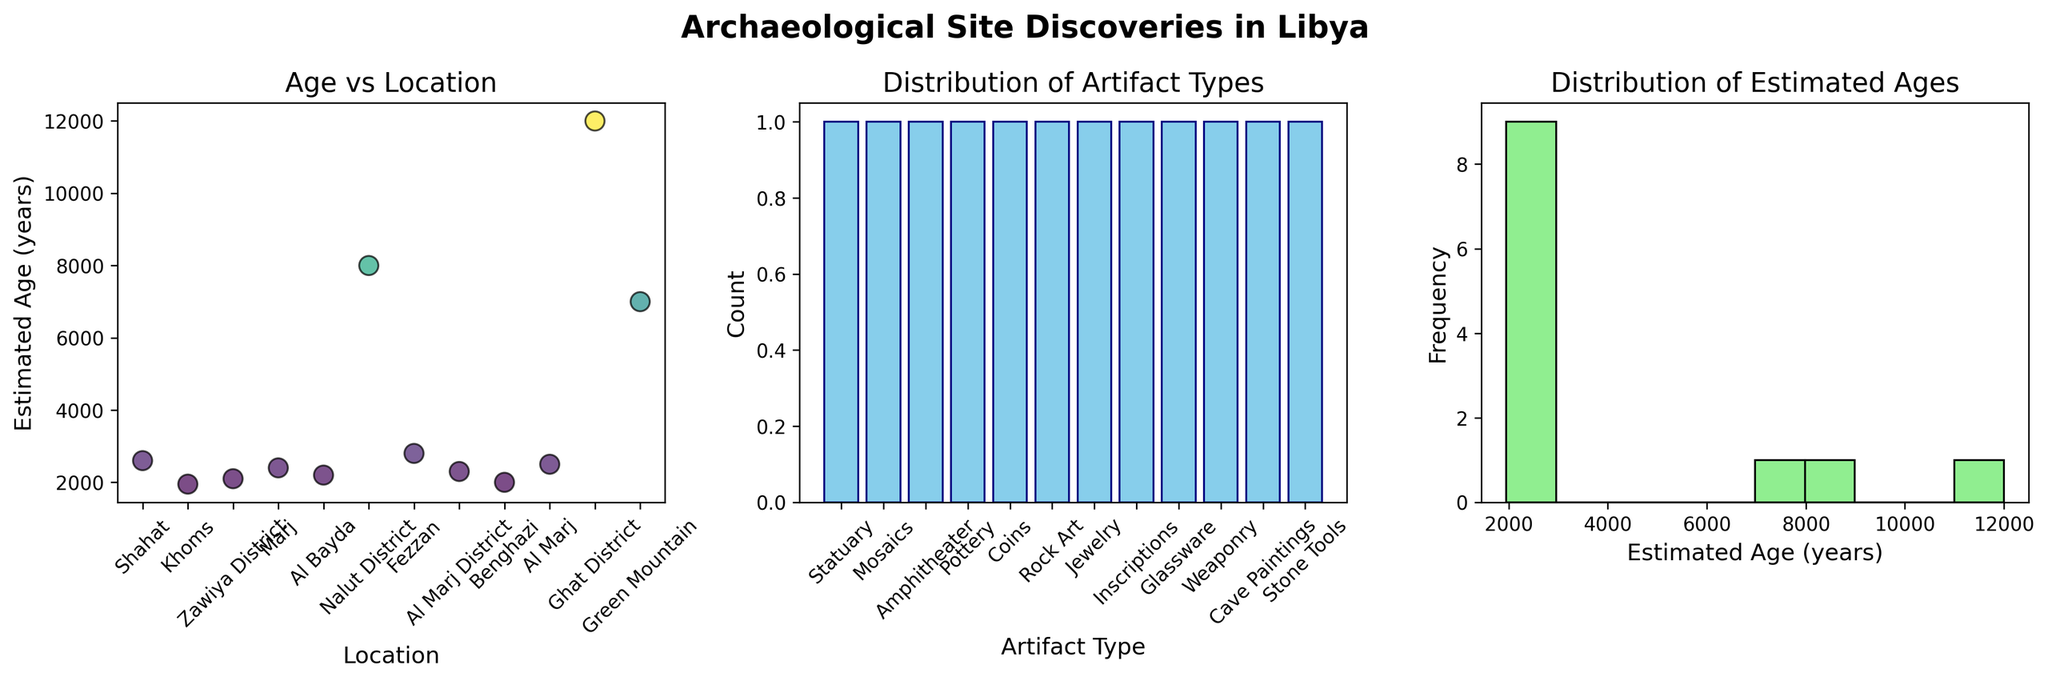What is the title of the scatter plot showing the relationship between location and estimated age? The title of the scatter plot is usually displayed at the top of the relevant plot.
Answer: Age vs Location Which location has the oldest estimated age for artifacts? By examining the scatter plot, locate the highest point along the y-axis (representing estimated age) and trace it back to the corresponding location on the x-axis.
Answer: Tadrart Acacus How many artifact types are shown in the bar plot? Count the distinct bars in the bar plot representing different artifact types.
Answer: 11 What is the most common artifact type found according to the bar plot? Look for the tallest bar in the bar plot, which represents the artifact type with the highest count.
Answer: Jewelry What is the range of the estimated ages in the histogram? Identify the lowest and highest values along the x-axis of the histogram to determine the range of estimated ages.
Answer: 800 to 12000 years Which location has the lowest estimated age for artifacts? By examining the scatter plot, locate the lowest point along the y-axis (representing estimated age) and trace it to the corresponding location on the x-axis.
Answer: Ghadames How does the distribution of artifact types compare to the distribution of estimated ages? Compare the bar plot (artifact types) and the histogram (estimated ages) to see how often different artifact types appear versus the frequency distribution of ages.
Answer: Artifact types are more evenly distributed compared to the skewed distribution of ages toward older artifacts What is the estimated age of artifacts found at Cyrene? Locate the point corresponding to Cyrene on the scatter plot and read the value on the y-axis to find the estimated age.
Answer: 2600 years Which artifact type has the widest age range? For each artifact type, examine the range of ages on the scatter plot to determine which one spans the greatest difference in years.
Answer: Not determinable from the bar plot alone; requires cross-checking artifact types with ages in the scatter plot What is the median estimated age of all the artifacts found? To find the median, sort all the estimated age values in ascending order and find the middle value. The ages are 800, 1950, 2000, 2100, 2200, 2300, 2400, 2500, 2600, 2800, 7000, 12000. The middle values (for an even number of data points) are the 6th and 7th values. Average these: (2200 + 2300)/2.
Answer: 2250 years 